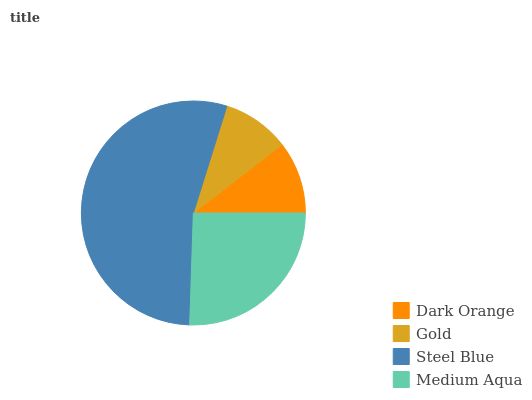Is Gold the minimum?
Answer yes or no. Yes. Is Steel Blue the maximum?
Answer yes or no. Yes. Is Steel Blue the minimum?
Answer yes or no. No. Is Gold the maximum?
Answer yes or no. No. Is Steel Blue greater than Gold?
Answer yes or no. Yes. Is Gold less than Steel Blue?
Answer yes or no. Yes. Is Gold greater than Steel Blue?
Answer yes or no. No. Is Steel Blue less than Gold?
Answer yes or no. No. Is Medium Aqua the high median?
Answer yes or no. Yes. Is Dark Orange the low median?
Answer yes or no. Yes. Is Dark Orange the high median?
Answer yes or no. No. Is Gold the low median?
Answer yes or no. No. 